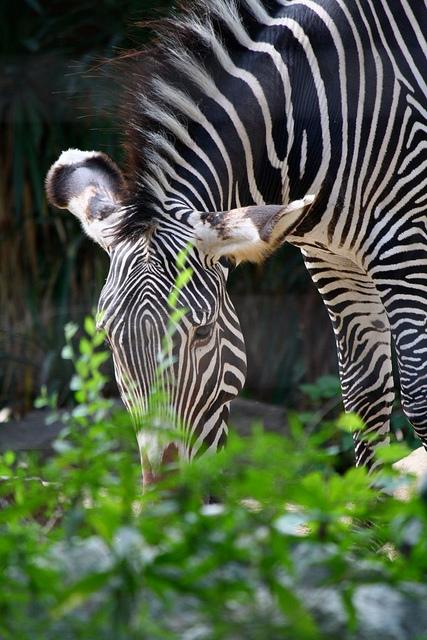What kind of animal is it?
Give a very brief answer. Zebra. Is the animal eating?
Short answer required. Yes. Is it day or night?
Write a very short answer. Day. 